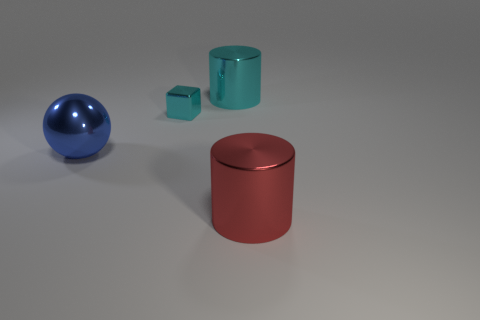Add 1 cyan cylinders. How many objects exist? 5 Subtract all cubes. How many objects are left? 3 Subtract all small cyan blocks. Subtract all large blue shiny balls. How many objects are left? 2 Add 2 large blue metallic objects. How many large blue metallic objects are left? 3 Add 1 large cyan matte cylinders. How many large cyan matte cylinders exist? 1 Subtract 0 red blocks. How many objects are left? 4 